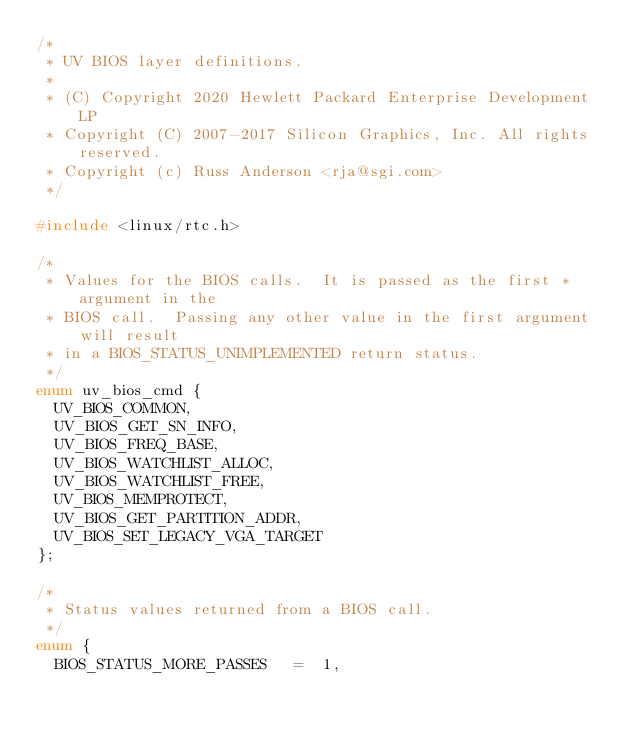Convert code to text. <code><loc_0><loc_0><loc_500><loc_500><_C_>/*
 * UV BIOS layer definitions.
 *
 * (C) Copyright 2020 Hewlett Packard Enterprise Development LP
 * Copyright (C) 2007-2017 Silicon Graphics, Inc. All rights reserved.
 * Copyright (c) Russ Anderson <rja@sgi.com>
 */

#include <linux/rtc.h>

/*
 * Values for the BIOS calls.  It is passed as the first * argument in the
 * BIOS call.  Passing any other value in the first argument will result
 * in a BIOS_STATUS_UNIMPLEMENTED return status.
 */
enum uv_bios_cmd {
	UV_BIOS_COMMON,
	UV_BIOS_GET_SN_INFO,
	UV_BIOS_FREQ_BASE,
	UV_BIOS_WATCHLIST_ALLOC,
	UV_BIOS_WATCHLIST_FREE,
	UV_BIOS_MEMPROTECT,
	UV_BIOS_GET_PARTITION_ADDR,
	UV_BIOS_SET_LEGACY_VGA_TARGET
};

/*
 * Status values returned from a BIOS call.
 */
enum {
	BIOS_STATUS_MORE_PASSES		=  1,</code> 